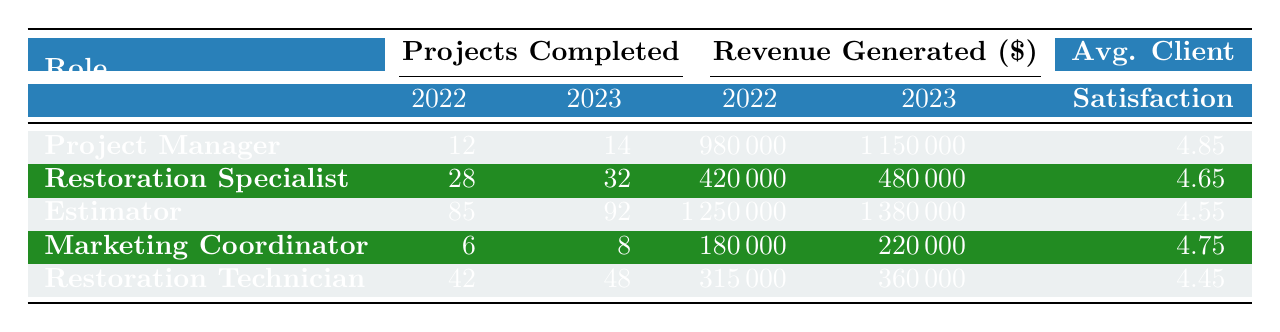What is the total revenue generated by Estimators in 2022 and 2023? The total revenue generated by Estimators can be calculated by adding the revenue for both years: 1,250,000 (2022) + 1,380,000 (2023) = 2,630,000.
Answer: 2,630,000 Which role had the highest average client satisfaction score over the two years? To find the highest average client satisfaction score, calculate the average for each role: Project Manager (4.85), Restoration Specialist (4.65), Estimator (4.55), Marketing Coordinator (4.75), Restoration Technician (4.45). The highest is from Project Manager at 4.85.
Answer: Project Manager Did the number of projects completed by the Restoration Specialist increase from 2022 to 2023? Compare the projects completed: 28 (2022) and 32 (2023). Since 32 is greater than 28, the number of projects completed increased.
Answer: Yes What is the difference in projects completed by Restoration Technicians between 2022 and 2023? Subtract the number of projects for 2022 from 2023: 48 (2023) - 42 (2022) = 6.
Answer: 6 Is the revenue generated by Marketing Coordinators higher in 2023 than in 2022? Compare the revenue generated: 220,000 (2023) compared to 180,000 (2022). Since 220,000 is greater than 180,000, the revenue is higher.
Answer: Yes What is the average number of projects completed by all roles in 2023? Sum the projects completed in 2023 (14 + 32 + 92 + 8 + 48 = 194) and divide by the number of roles (5): 194 / 5 = 38.8.
Answer: 38.8 Which role showed the greatest increase in revenue generated from 2022 to 2023? Calculate the revenue increase for each role: Project Manager (170,000), Restoration Specialist (60,000), Estimator (130,000), Marketing Coordinator (40,000), Restoration Technician (45,000). The greatest increase is by the Estimator with 130,000.
Answer: Estimator What role had the lowest client satisfaction score in 2023? Identify the scores: Project Manager (4.9), Restoration Specialist (4.7), Estimator (4.6), Marketing Coordinator (4.8), Restoration Technician (4.5). The lowest is from Restoration Technician at 4.5.
Answer: Restoration Technician 